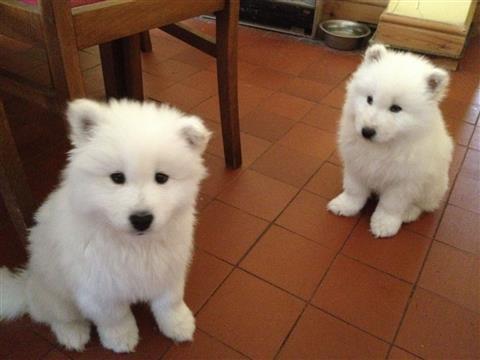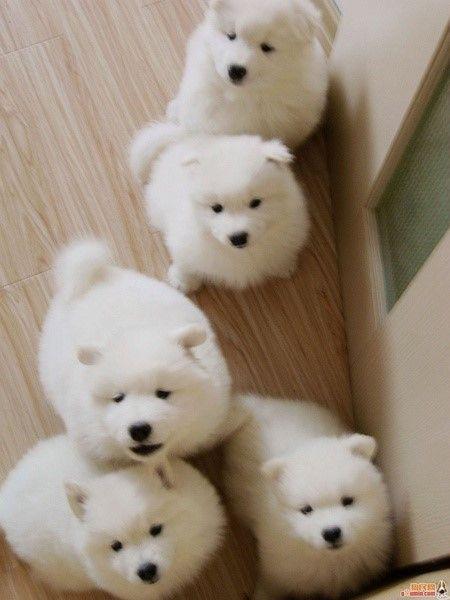The first image is the image on the left, the second image is the image on the right. Analyze the images presented: Is the assertion "Each image contains exactly one reclining white dog." valid? Answer yes or no. No. 